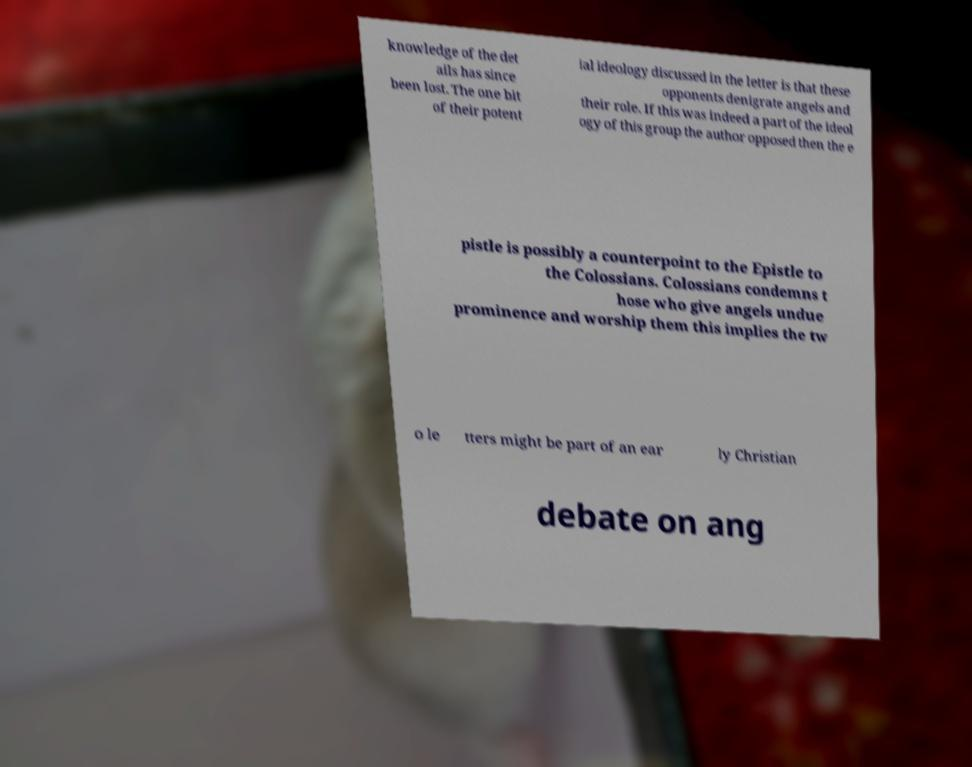Please identify and transcribe the text found in this image. knowledge of the det ails has since been lost. The one bit of their potent ial ideology discussed in the letter is that these opponents denigrate angels and their role. If this was indeed a part of the ideol ogy of this group the author opposed then the e pistle is possibly a counterpoint to the Epistle to the Colossians. Colossians condemns t hose who give angels undue prominence and worship them this implies the tw o le tters might be part of an ear ly Christian debate on ang 